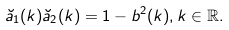Convert formula to latex. <formula><loc_0><loc_0><loc_500><loc_500>\breve { a } _ { 1 } ( k ) \breve { a } _ { 2 } ( k ) = 1 - b ^ { 2 } ( k ) , k \in \mathbb { R } .</formula> 